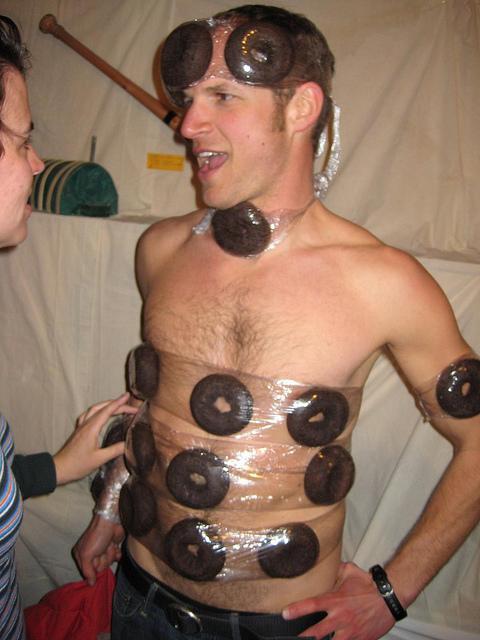How many people are there?
Give a very brief answer. 2. How many baseball bats are there?
Give a very brief answer. 1. How many donuts can you see?
Give a very brief answer. 9. 